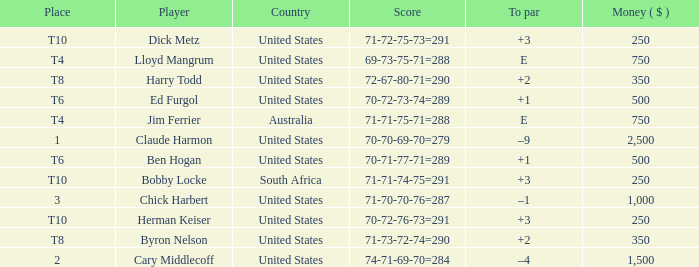What is the to par for the player from the United States with a 72-67-80-71=290 score? 2.0. 